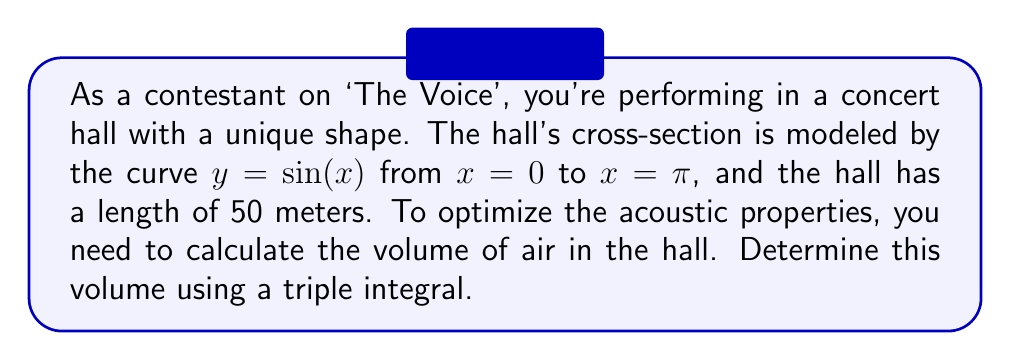Could you help me with this problem? To solve this problem, we'll follow these steps:

1) The volume of the concert hall can be represented by a triple integral. We'll integrate over x, y, and z, where z represents the length of the hall.

2) The limits of integration are:
   x: from 0 to π
   y: from 0 to sin(x)
   z: from 0 to 50

3) The triple integral will be:

   $$V = \int_0^{50} \int_0^{\pi} \int_0^{\sin(x)} 1 \, dy \, dx \, dz$$

4) Let's solve the innermost integral first:

   $$\int_0^{\sin(x)} 1 \, dy = y \big|_0^{\sin(x)} = \sin(x)$$

5) Now our integral becomes:

   $$V = \int_0^{50} \int_0^{\pi} \sin(x) \, dx \, dz$$

6) Solve the integral with respect to x:

   $$\int_0^{\pi} \sin(x) \, dx = -\cos(x) \big|_0^{\pi} = -(\cos(\pi) - \cos(0)) = 2$$

7) Our integral is now:

   $$V = \int_0^{50} 2 \, dz = 2z \big|_0^{50} = 100$$

8) Therefore, the volume of the concert hall is 100 cubic meters.
Answer: 100 m³ 